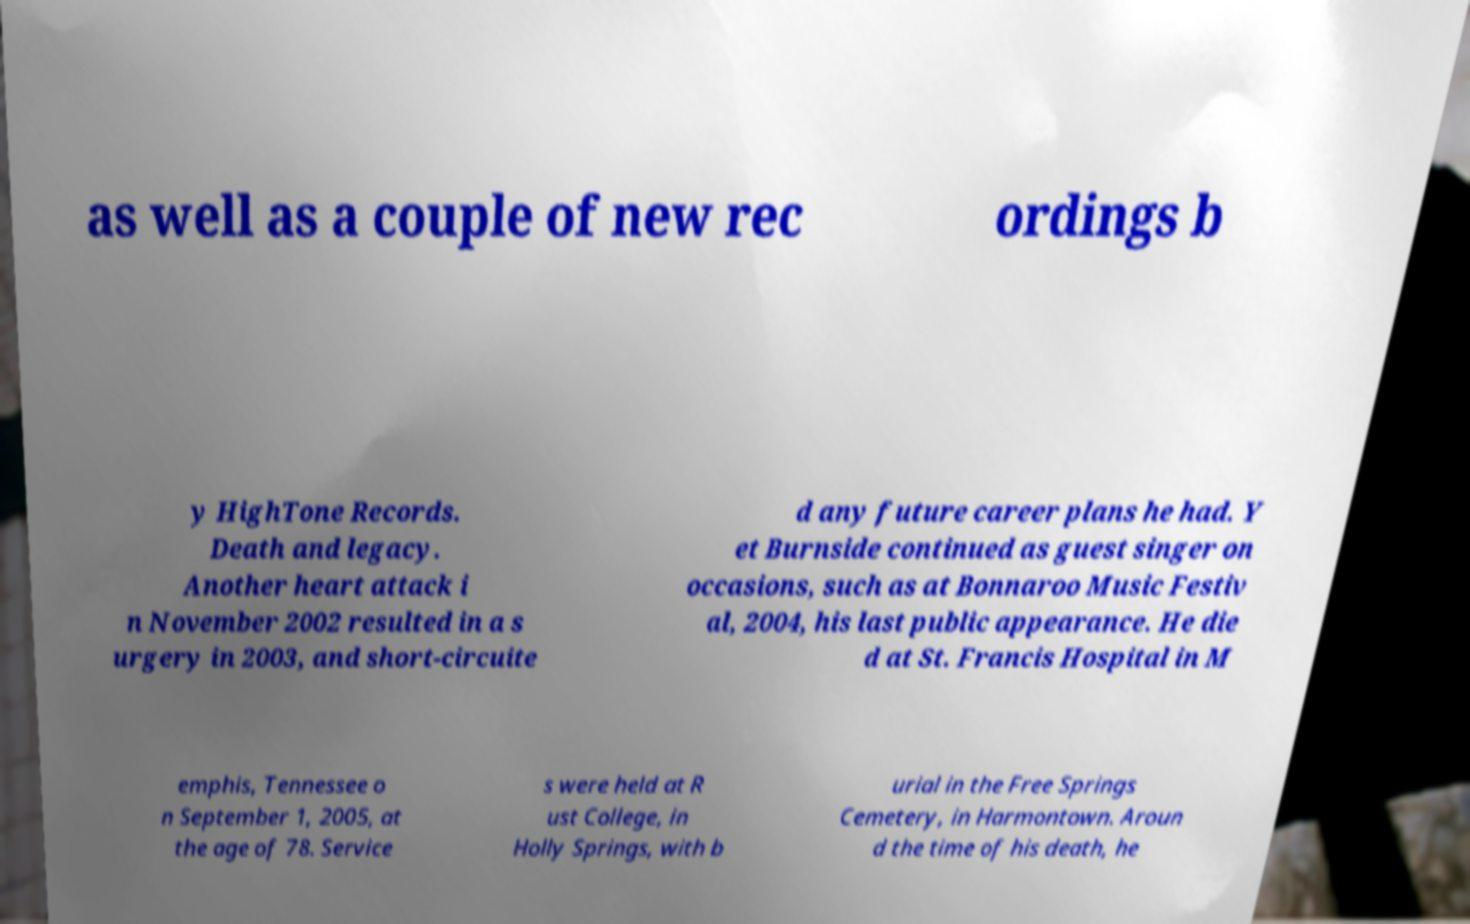Please identify and transcribe the text found in this image. as well as a couple of new rec ordings b y HighTone Records. Death and legacy. Another heart attack i n November 2002 resulted in a s urgery in 2003, and short-circuite d any future career plans he had. Y et Burnside continued as guest singer on occasions, such as at Bonnaroo Music Festiv al, 2004, his last public appearance. He die d at St. Francis Hospital in M emphis, Tennessee o n September 1, 2005, at the age of 78. Service s were held at R ust College, in Holly Springs, with b urial in the Free Springs Cemetery, in Harmontown. Aroun d the time of his death, he 